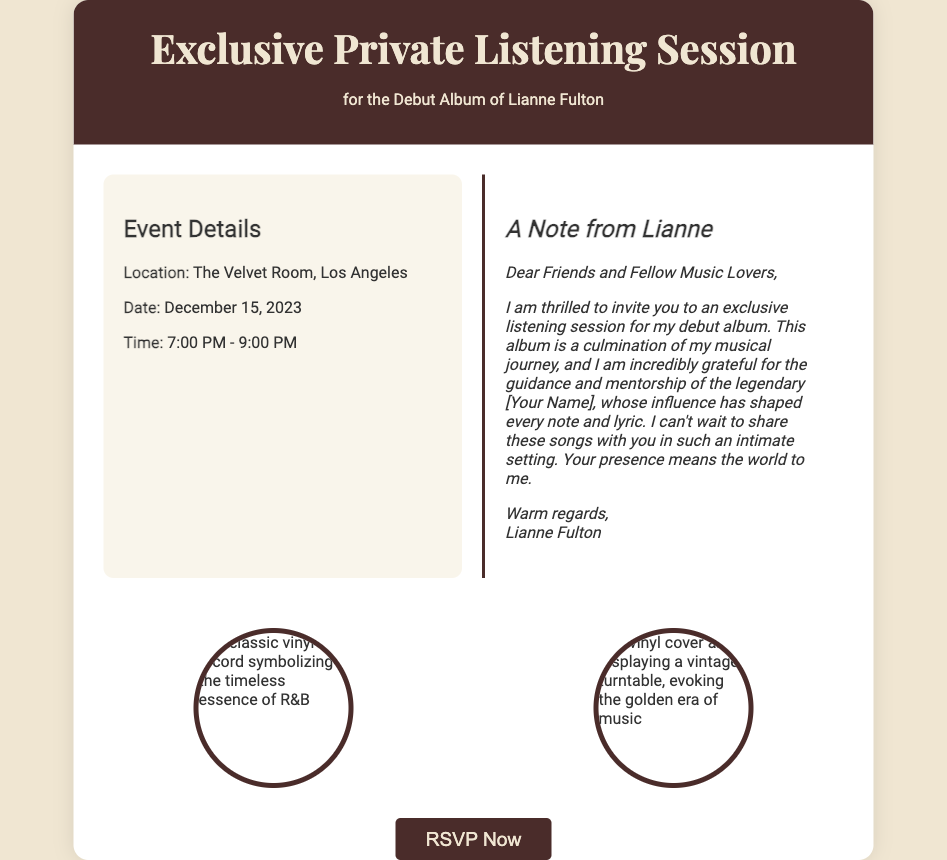What is the title of the event? The title of the event is stated prominently at the top of the document, announcing it as an exclusive private listening session.
Answer: Exclusive Private Listening Session Who is the artist for the debut album? The document mentions Lianne Fulton as the artist for the debut album in both the title and the event details.
Answer: Lianne Fulton What date is the listening session scheduled for? The date is explicitly mentioned in the event details section of the document.
Answer: December 15, 2023 What is the location of the event? The location is specified in the event details section of the document.
Answer: The Velvet Room, Los Angeles What time does the listening session begin? The start time is provided alongside the end time in the event details section.
Answer: 7:00 PM What is the main purpose of the event? The purpose is indicated in the title and note, focused on sharing Lianne Fulton’s debut album with attendees.
Answer: Debut Album Listening Session How does Lianne describe her gratitude towards her mentor? She expresses gratitude toward her mentor, indicating their influence on her music.
Answer: Incredibly grateful for the guidance and mentorship How long will the event last? The duration of the event can be inferred from the start and end times provided in the document.
Answer: 2 hours What type of images are included in the document? The document features images that symbolize a connection to music and the vinyl era, specifically mentioning vinyl records.
Answer: Vinyl records 